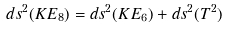Convert formula to latex. <formula><loc_0><loc_0><loc_500><loc_500>d s ^ { 2 } ( K E _ { 8 } ) = d s ^ { 2 } ( K E _ { 6 } ) + d s ^ { 2 } ( T ^ { 2 } )</formula> 